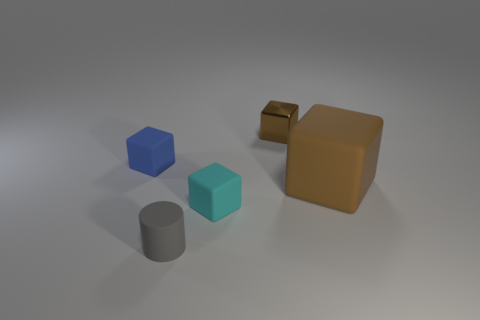There is another big thing that is the same shape as the brown metal object; what material is it?
Offer a terse response. Rubber. How many tiny matte things have the same shape as the big brown object?
Your response must be concise. 2. There is a brown object that is on the left side of the big brown rubber block; is its shape the same as the large brown object?
Your answer should be compact. Yes. What material is the brown object that is the same size as the gray object?
Your answer should be compact. Metal. Is the shape of the large brown rubber thing the same as the tiny object left of the tiny gray object?
Give a very brief answer. Yes. Do the tiny brown block and the small block that is in front of the large object have the same material?
Offer a very short reply. No. Are there the same number of blue matte cubes that are behind the cyan rubber object and gray matte things?
Make the answer very short. Yes. There is a matte cube in front of the large rubber thing; what is its color?
Your answer should be compact. Cyan. How many other things are the same color as the big object?
Make the answer very short. 1. Are there any other things that are the same size as the brown rubber thing?
Ensure brevity in your answer.  No. 